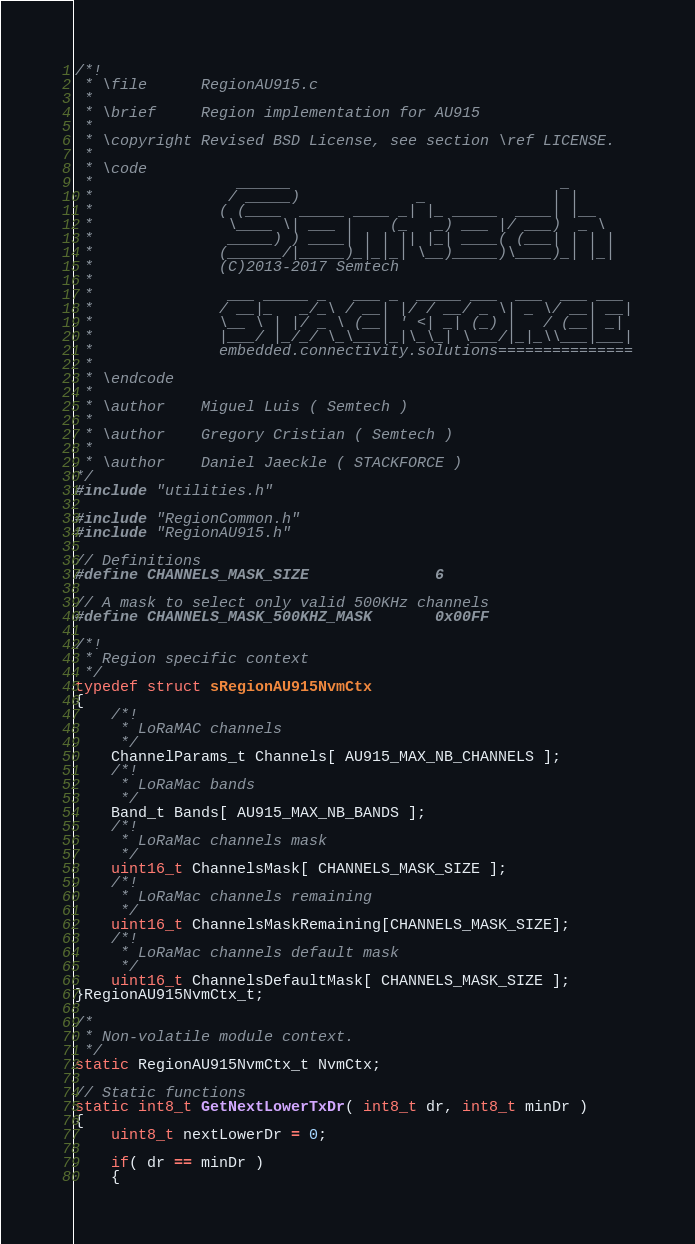Convert code to text. <code><loc_0><loc_0><loc_500><loc_500><_C_>/*!
 * \file      RegionAU915.c
 *
 * \brief     Region implementation for AU915
 *
 * \copyright Revised BSD License, see section \ref LICENSE.
 *
 * \code
 *                ______                              _
 *               / _____)             _              | |
 *              ( (____  _____ ____ _| |_ _____  ____| |__
 *               \____ \| ___ |    (_   _) ___ |/ ___)  _ \
 *               _____) ) ____| | | || |_| ____( (___| | | |
 *              (______/|_____)_|_|_| \__)_____)\____)_| |_|
 *              (C)2013-2017 Semtech
 *
 *               ___ _____ _   ___ _  _____ ___  ___  ___ ___
 *              / __|_   _/_\ / __| |/ / __/ _ \| _ \/ __| __|
 *              \__ \ | |/ _ \ (__| ' <| _| (_) |   / (__| _|
 *              |___/ |_/_/ \_\___|_|\_\_| \___/|_|_\\___|___|
 *              embedded.connectivity.solutions===============
 *
 * \endcode
 *
 * \author    Miguel Luis ( Semtech )
 *
 * \author    Gregory Cristian ( Semtech )
 *
 * \author    Daniel Jaeckle ( STACKFORCE )
*/
#include "utilities.h"

#include "RegionCommon.h"
#include "RegionAU915.h"

// Definitions
#define CHANNELS_MASK_SIZE              6

// A mask to select only valid 500KHz channels
#define CHANNELS_MASK_500KHZ_MASK       0x00FF

/*!
 * Region specific context
 */
typedef struct sRegionAU915NvmCtx
{
    /*!
     * LoRaMAC channels
     */
    ChannelParams_t Channels[ AU915_MAX_NB_CHANNELS ];
    /*!
     * LoRaMac bands
     */
    Band_t Bands[ AU915_MAX_NB_BANDS ];
    /*!
     * LoRaMac channels mask
     */
    uint16_t ChannelsMask[ CHANNELS_MASK_SIZE ];
    /*!
     * LoRaMac channels remaining
     */
    uint16_t ChannelsMaskRemaining[CHANNELS_MASK_SIZE];
    /*!
     * LoRaMac channels default mask
     */
    uint16_t ChannelsDefaultMask[ CHANNELS_MASK_SIZE ];
}RegionAU915NvmCtx_t;

/*
 * Non-volatile module context.
 */
static RegionAU915NvmCtx_t NvmCtx;

// Static functions
static int8_t GetNextLowerTxDr( int8_t dr, int8_t minDr )
{
    uint8_t nextLowerDr = 0;

    if( dr == minDr )
    {</code> 